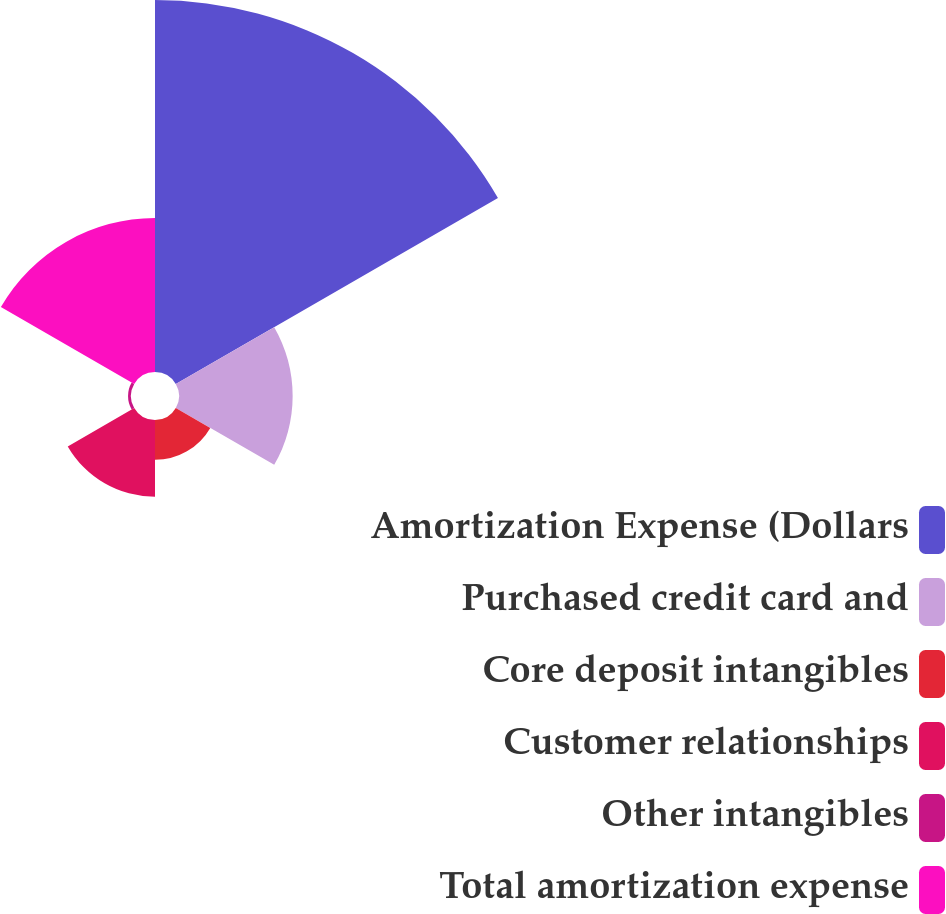Convert chart to OTSL. <chart><loc_0><loc_0><loc_500><loc_500><pie_chart><fcel>Amortization Expense (Dollars<fcel>Purchased credit card and<fcel>Core deposit intangibles<fcel>Customer relationships<fcel>Other intangibles<fcel>Total amortization expense<nl><fcel>49.0%<fcel>14.97%<fcel>5.25%<fcel>10.11%<fcel>0.39%<fcel>20.28%<nl></chart> 